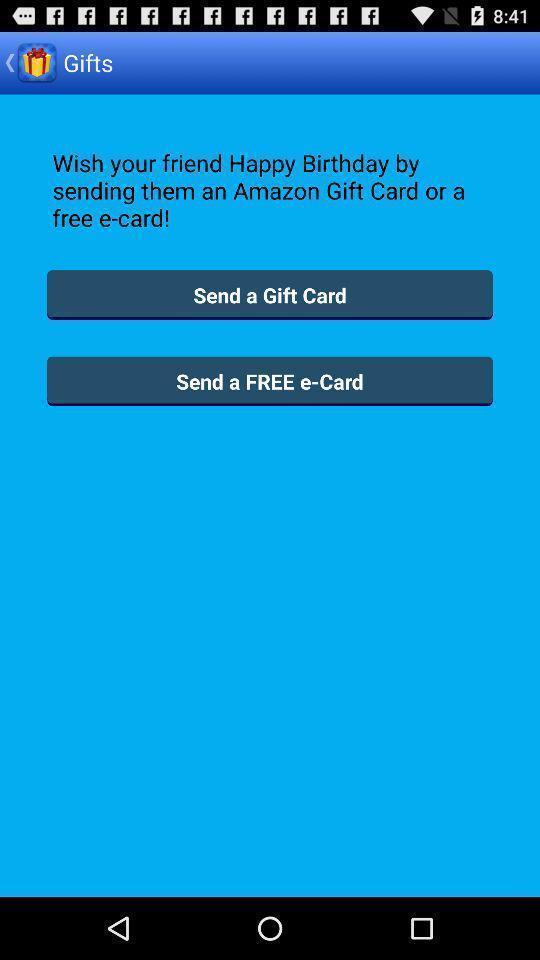What can you discern from this picture? Send a gift card with gift app. 